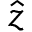Convert formula to latex. <formula><loc_0><loc_0><loc_500><loc_500>\hat { z }</formula> 